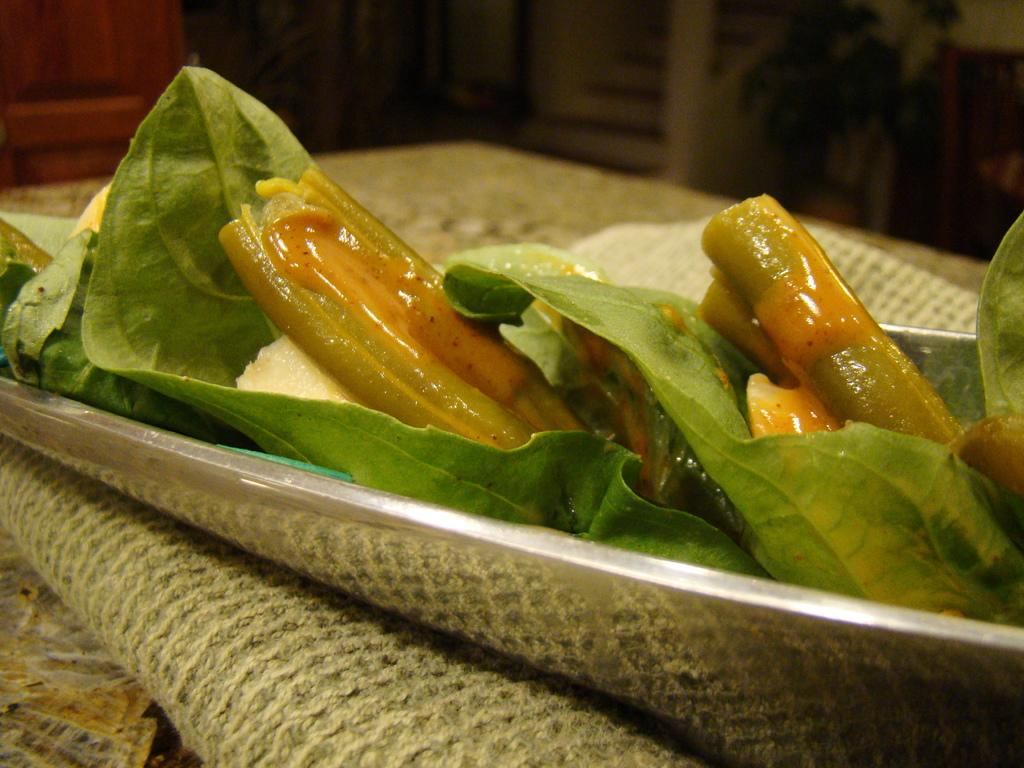What is located in the center of the image? There is a mat in the center of the image. What is placed on the mat? There is a tray on the mat. What can be found inside the tray? There are food items in the tray. Which direction is the pear facing in the image? There is no pear present in the image. 